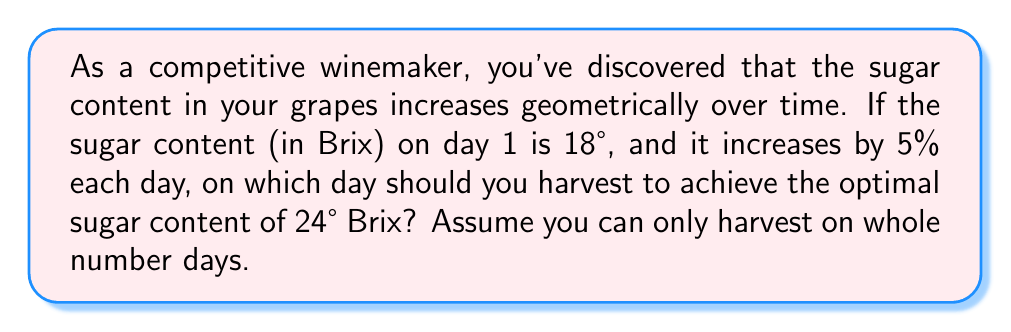Can you solve this math problem? Let's approach this step-by-step using a geometric sequence:

1) Initial term (a₁) = 18° Brix
2) Common ratio (r) = 1.05 (5% increase = 1 + 0.05)
3) We need to find n (number of days) where aₙ ≥ 24° Brix

The general term of a geometric sequence is given by:
$$a_n = a_1 \cdot r^{n-1}$$

We need to solve:
$$18 \cdot 1.05^{n-1} \geq 24$$

Dividing both sides by 18:
$$1.05^{n-1} \geq \frac{24}{18} = \frac{4}{3}$$

Taking logarithms of both sides:
$$(n-1) \log(1.05) \geq \log(\frac{4}{3})$$

Solving for n:
$$n \geq 1 + \frac{\log(\frac{4}{3})}{\log(1.05)} \approx 6.02$$

Since we can only harvest on whole number days, we need to round up to the next integer.
Answer: 7 days 